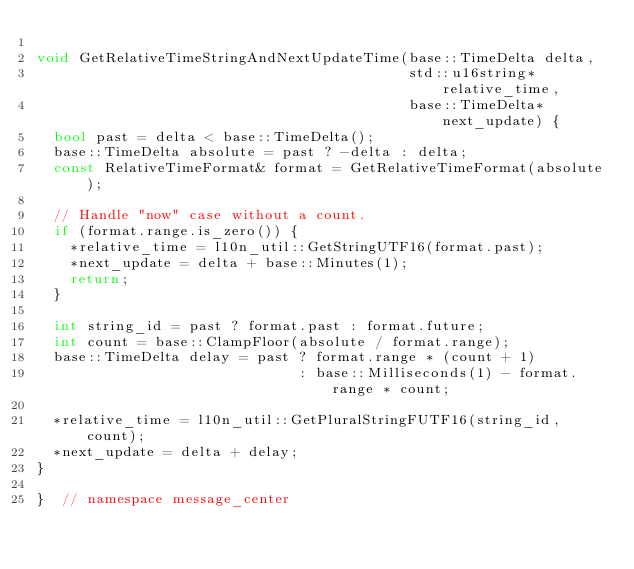Convert code to text. <code><loc_0><loc_0><loc_500><loc_500><_C++_>
void GetRelativeTimeStringAndNextUpdateTime(base::TimeDelta delta,
                                            std::u16string* relative_time,
                                            base::TimeDelta* next_update) {
  bool past = delta < base::TimeDelta();
  base::TimeDelta absolute = past ? -delta : delta;
  const RelativeTimeFormat& format = GetRelativeTimeFormat(absolute);

  // Handle "now" case without a count.
  if (format.range.is_zero()) {
    *relative_time = l10n_util::GetStringUTF16(format.past);
    *next_update = delta + base::Minutes(1);
    return;
  }

  int string_id = past ? format.past : format.future;
  int count = base::ClampFloor(absolute / format.range);
  base::TimeDelta delay = past ? format.range * (count + 1)
                               : base::Milliseconds(1) - format.range * count;

  *relative_time = l10n_util::GetPluralStringFUTF16(string_id, count);
  *next_update = delta + delay;
}

}  // namespace message_center
</code> 